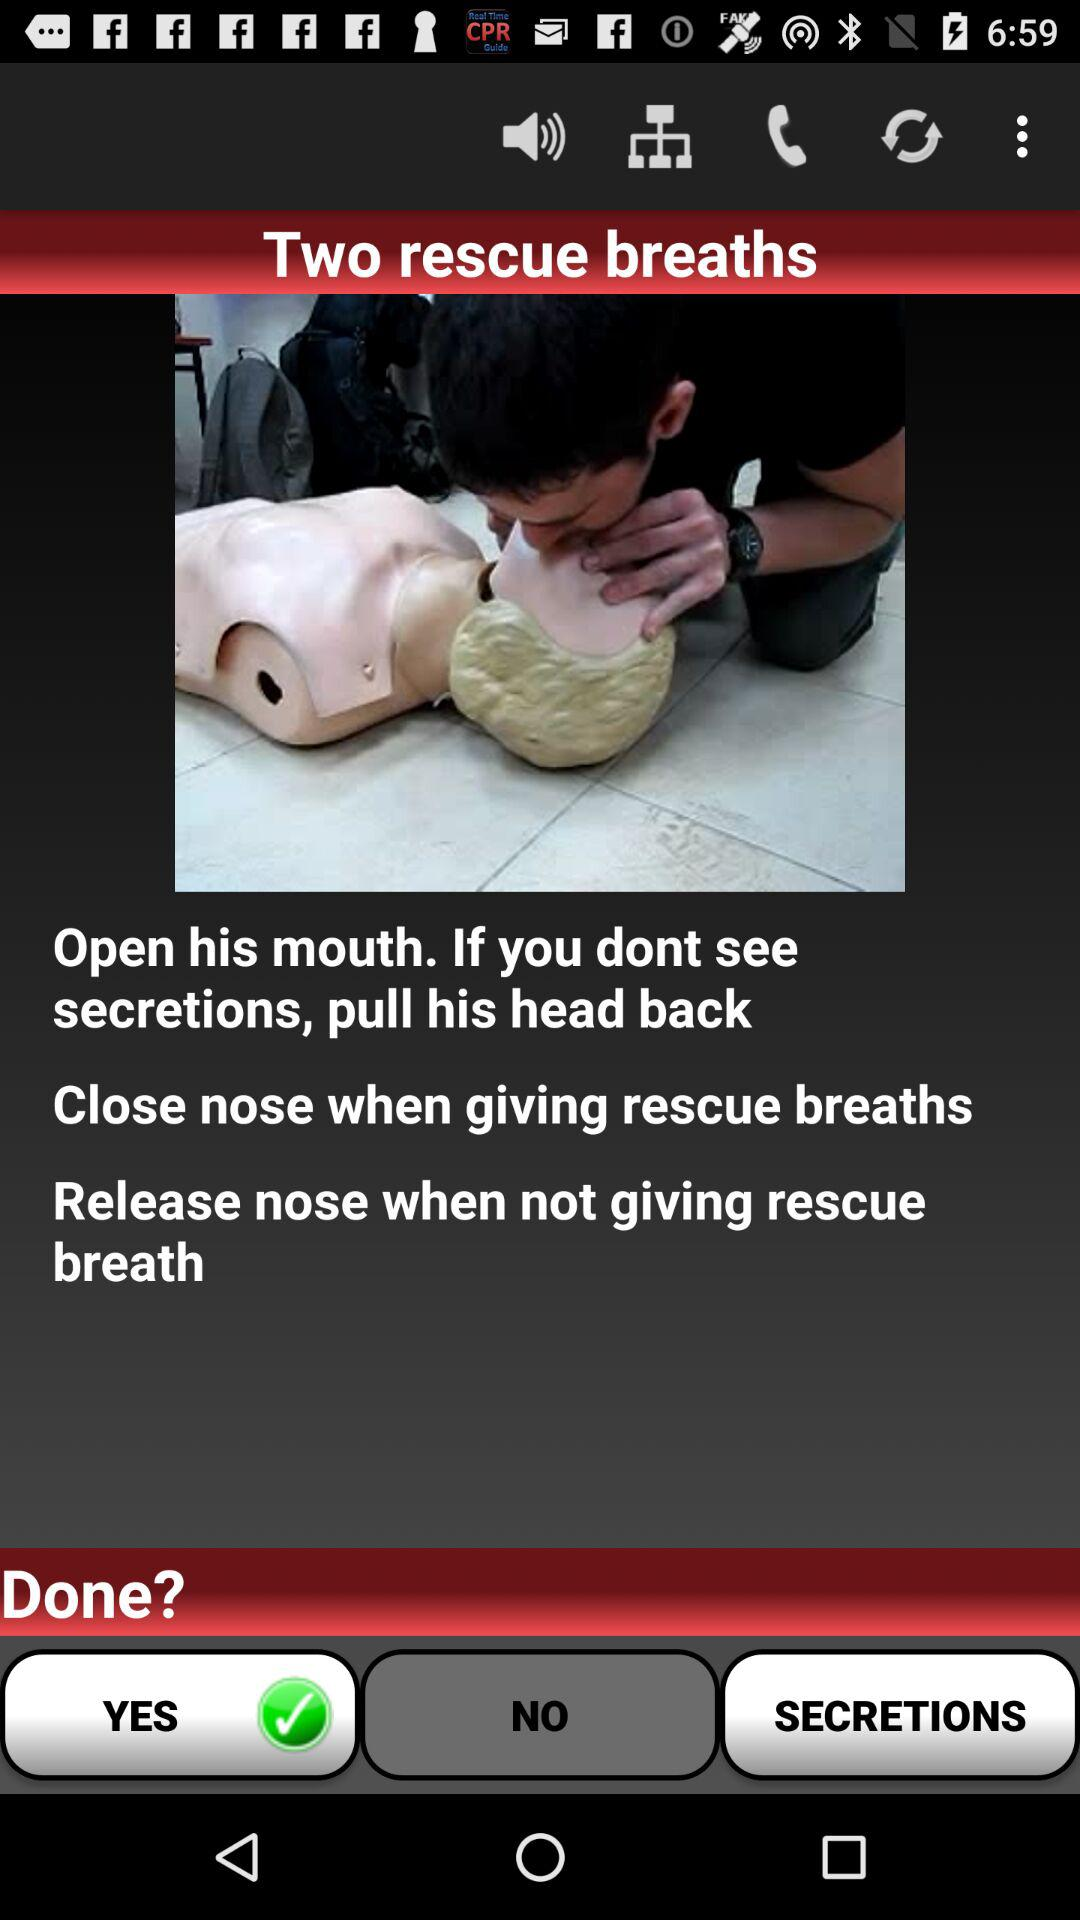How many steps are there in the CPR process?
Answer the question using a single word or phrase. 3 